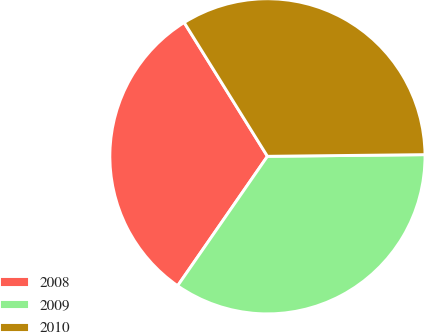Convert chart to OTSL. <chart><loc_0><loc_0><loc_500><loc_500><pie_chart><fcel>2008<fcel>2009<fcel>2010<nl><fcel>31.49%<fcel>34.82%<fcel>33.69%<nl></chart> 